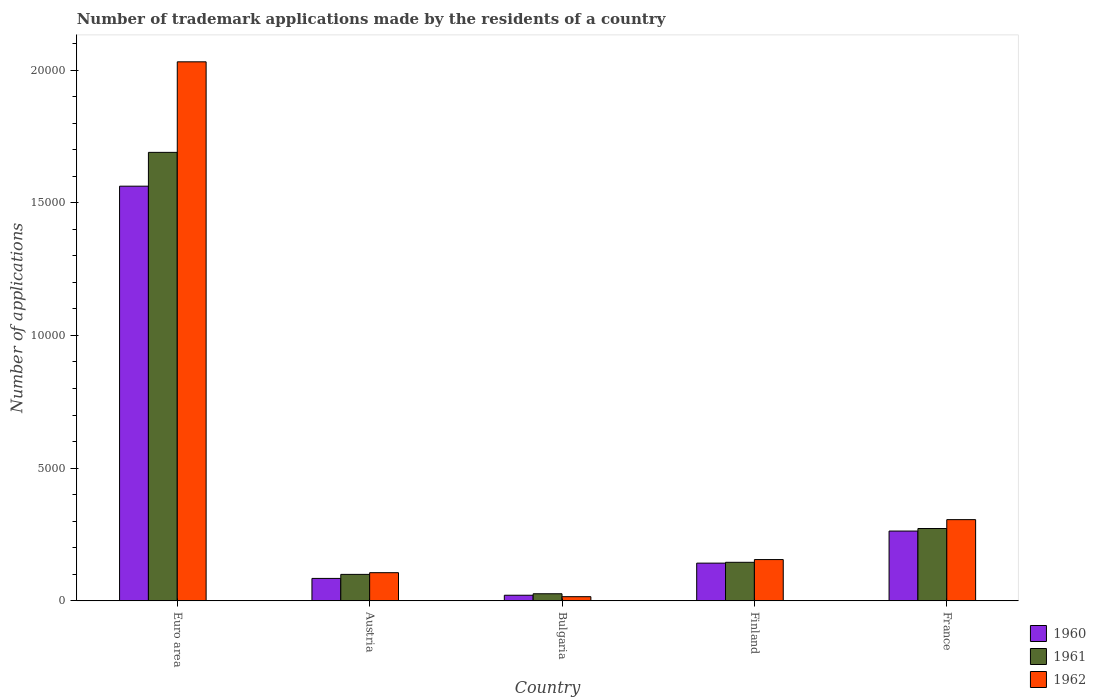How many groups of bars are there?
Provide a succinct answer. 5. Are the number of bars on each tick of the X-axis equal?
Provide a short and direct response. Yes. What is the label of the 4th group of bars from the left?
Ensure brevity in your answer.  Finland. In how many cases, is the number of bars for a given country not equal to the number of legend labels?
Make the answer very short. 0. What is the number of trademark applications made by the residents in 1962 in Euro area?
Make the answer very short. 2.03e+04. Across all countries, what is the maximum number of trademark applications made by the residents in 1960?
Your response must be concise. 1.56e+04. Across all countries, what is the minimum number of trademark applications made by the residents in 1962?
Provide a succinct answer. 157. In which country was the number of trademark applications made by the residents in 1960 minimum?
Provide a succinct answer. Bulgaria. What is the total number of trademark applications made by the residents in 1962 in the graph?
Provide a succinct answer. 2.61e+04. What is the difference between the number of trademark applications made by the residents in 1962 in Bulgaria and that in France?
Ensure brevity in your answer.  -2903. What is the difference between the number of trademark applications made by the residents in 1960 in Bulgaria and the number of trademark applications made by the residents in 1962 in Finland?
Offer a very short reply. -1344. What is the average number of trademark applications made by the residents in 1961 per country?
Provide a short and direct response. 4468.2. What is the difference between the number of trademark applications made by the residents of/in 1962 and number of trademark applications made by the residents of/in 1960 in Austria?
Your answer should be very brief. 216. What is the ratio of the number of trademark applications made by the residents in 1960 in Austria to that in France?
Make the answer very short. 0.32. What is the difference between the highest and the second highest number of trademark applications made by the residents in 1962?
Offer a terse response. -1505. What is the difference between the highest and the lowest number of trademark applications made by the residents in 1962?
Provide a short and direct response. 2.02e+04. In how many countries, is the number of trademark applications made by the residents in 1961 greater than the average number of trademark applications made by the residents in 1961 taken over all countries?
Provide a short and direct response. 1. Is the sum of the number of trademark applications made by the residents in 1962 in Euro area and France greater than the maximum number of trademark applications made by the residents in 1960 across all countries?
Make the answer very short. Yes. What does the 2nd bar from the left in Euro area represents?
Give a very brief answer. 1961. Is it the case that in every country, the sum of the number of trademark applications made by the residents in 1962 and number of trademark applications made by the residents in 1961 is greater than the number of trademark applications made by the residents in 1960?
Offer a very short reply. Yes. How many countries are there in the graph?
Offer a very short reply. 5. Are the values on the major ticks of Y-axis written in scientific E-notation?
Your answer should be compact. No. Does the graph contain any zero values?
Make the answer very short. No. How many legend labels are there?
Ensure brevity in your answer.  3. How are the legend labels stacked?
Provide a short and direct response. Vertical. What is the title of the graph?
Offer a terse response. Number of trademark applications made by the residents of a country. What is the label or title of the Y-axis?
Your answer should be very brief. Number of applications. What is the Number of applications in 1960 in Euro area?
Keep it short and to the point. 1.56e+04. What is the Number of applications in 1961 in Euro area?
Make the answer very short. 1.69e+04. What is the Number of applications of 1962 in Euro area?
Provide a succinct answer. 2.03e+04. What is the Number of applications in 1960 in Austria?
Your response must be concise. 845. What is the Number of applications of 1961 in Austria?
Offer a terse response. 997. What is the Number of applications of 1962 in Austria?
Offer a terse response. 1061. What is the Number of applications of 1960 in Bulgaria?
Your answer should be very brief. 211. What is the Number of applications of 1961 in Bulgaria?
Offer a very short reply. 267. What is the Number of applications in 1962 in Bulgaria?
Keep it short and to the point. 157. What is the Number of applications of 1960 in Finland?
Your response must be concise. 1421. What is the Number of applications of 1961 in Finland?
Offer a terse response. 1452. What is the Number of applications in 1962 in Finland?
Keep it short and to the point. 1555. What is the Number of applications of 1960 in France?
Offer a very short reply. 2630. What is the Number of applications of 1961 in France?
Make the answer very short. 2726. What is the Number of applications of 1962 in France?
Ensure brevity in your answer.  3060. Across all countries, what is the maximum Number of applications in 1960?
Provide a short and direct response. 1.56e+04. Across all countries, what is the maximum Number of applications in 1961?
Your answer should be very brief. 1.69e+04. Across all countries, what is the maximum Number of applications of 1962?
Ensure brevity in your answer.  2.03e+04. Across all countries, what is the minimum Number of applications of 1960?
Your response must be concise. 211. Across all countries, what is the minimum Number of applications in 1961?
Your answer should be very brief. 267. Across all countries, what is the minimum Number of applications of 1962?
Provide a succinct answer. 157. What is the total Number of applications of 1960 in the graph?
Provide a short and direct response. 2.07e+04. What is the total Number of applications of 1961 in the graph?
Provide a succinct answer. 2.23e+04. What is the total Number of applications of 1962 in the graph?
Offer a terse response. 2.61e+04. What is the difference between the Number of applications of 1960 in Euro area and that in Austria?
Keep it short and to the point. 1.48e+04. What is the difference between the Number of applications of 1961 in Euro area and that in Austria?
Make the answer very short. 1.59e+04. What is the difference between the Number of applications in 1962 in Euro area and that in Austria?
Make the answer very short. 1.92e+04. What is the difference between the Number of applications of 1960 in Euro area and that in Bulgaria?
Keep it short and to the point. 1.54e+04. What is the difference between the Number of applications of 1961 in Euro area and that in Bulgaria?
Offer a terse response. 1.66e+04. What is the difference between the Number of applications in 1962 in Euro area and that in Bulgaria?
Your answer should be compact. 2.02e+04. What is the difference between the Number of applications in 1960 in Euro area and that in Finland?
Provide a short and direct response. 1.42e+04. What is the difference between the Number of applications in 1961 in Euro area and that in Finland?
Your answer should be very brief. 1.54e+04. What is the difference between the Number of applications of 1962 in Euro area and that in Finland?
Offer a terse response. 1.88e+04. What is the difference between the Number of applications in 1960 in Euro area and that in France?
Make the answer very short. 1.30e+04. What is the difference between the Number of applications in 1961 in Euro area and that in France?
Offer a very short reply. 1.42e+04. What is the difference between the Number of applications in 1962 in Euro area and that in France?
Ensure brevity in your answer.  1.73e+04. What is the difference between the Number of applications in 1960 in Austria and that in Bulgaria?
Provide a succinct answer. 634. What is the difference between the Number of applications of 1961 in Austria and that in Bulgaria?
Your answer should be compact. 730. What is the difference between the Number of applications in 1962 in Austria and that in Bulgaria?
Offer a very short reply. 904. What is the difference between the Number of applications in 1960 in Austria and that in Finland?
Offer a terse response. -576. What is the difference between the Number of applications in 1961 in Austria and that in Finland?
Your answer should be very brief. -455. What is the difference between the Number of applications of 1962 in Austria and that in Finland?
Ensure brevity in your answer.  -494. What is the difference between the Number of applications of 1960 in Austria and that in France?
Offer a very short reply. -1785. What is the difference between the Number of applications of 1961 in Austria and that in France?
Give a very brief answer. -1729. What is the difference between the Number of applications of 1962 in Austria and that in France?
Ensure brevity in your answer.  -1999. What is the difference between the Number of applications of 1960 in Bulgaria and that in Finland?
Your answer should be compact. -1210. What is the difference between the Number of applications in 1961 in Bulgaria and that in Finland?
Provide a succinct answer. -1185. What is the difference between the Number of applications in 1962 in Bulgaria and that in Finland?
Make the answer very short. -1398. What is the difference between the Number of applications in 1960 in Bulgaria and that in France?
Keep it short and to the point. -2419. What is the difference between the Number of applications of 1961 in Bulgaria and that in France?
Provide a short and direct response. -2459. What is the difference between the Number of applications of 1962 in Bulgaria and that in France?
Offer a terse response. -2903. What is the difference between the Number of applications of 1960 in Finland and that in France?
Your response must be concise. -1209. What is the difference between the Number of applications of 1961 in Finland and that in France?
Make the answer very short. -1274. What is the difference between the Number of applications in 1962 in Finland and that in France?
Your answer should be compact. -1505. What is the difference between the Number of applications of 1960 in Euro area and the Number of applications of 1961 in Austria?
Give a very brief answer. 1.46e+04. What is the difference between the Number of applications of 1960 in Euro area and the Number of applications of 1962 in Austria?
Make the answer very short. 1.46e+04. What is the difference between the Number of applications in 1961 in Euro area and the Number of applications in 1962 in Austria?
Your answer should be very brief. 1.58e+04. What is the difference between the Number of applications in 1960 in Euro area and the Number of applications in 1961 in Bulgaria?
Your response must be concise. 1.54e+04. What is the difference between the Number of applications of 1960 in Euro area and the Number of applications of 1962 in Bulgaria?
Provide a succinct answer. 1.55e+04. What is the difference between the Number of applications in 1961 in Euro area and the Number of applications in 1962 in Bulgaria?
Give a very brief answer. 1.67e+04. What is the difference between the Number of applications in 1960 in Euro area and the Number of applications in 1961 in Finland?
Give a very brief answer. 1.42e+04. What is the difference between the Number of applications in 1960 in Euro area and the Number of applications in 1962 in Finland?
Offer a very short reply. 1.41e+04. What is the difference between the Number of applications of 1961 in Euro area and the Number of applications of 1962 in Finland?
Your answer should be compact. 1.53e+04. What is the difference between the Number of applications in 1960 in Euro area and the Number of applications in 1961 in France?
Provide a short and direct response. 1.29e+04. What is the difference between the Number of applications of 1960 in Euro area and the Number of applications of 1962 in France?
Offer a terse response. 1.26e+04. What is the difference between the Number of applications in 1961 in Euro area and the Number of applications in 1962 in France?
Offer a very short reply. 1.38e+04. What is the difference between the Number of applications of 1960 in Austria and the Number of applications of 1961 in Bulgaria?
Keep it short and to the point. 578. What is the difference between the Number of applications in 1960 in Austria and the Number of applications in 1962 in Bulgaria?
Ensure brevity in your answer.  688. What is the difference between the Number of applications in 1961 in Austria and the Number of applications in 1962 in Bulgaria?
Keep it short and to the point. 840. What is the difference between the Number of applications of 1960 in Austria and the Number of applications of 1961 in Finland?
Make the answer very short. -607. What is the difference between the Number of applications in 1960 in Austria and the Number of applications in 1962 in Finland?
Keep it short and to the point. -710. What is the difference between the Number of applications of 1961 in Austria and the Number of applications of 1962 in Finland?
Offer a terse response. -558. What is the difference between the Number of applications in 1960 in Austria and the Number of applications in 1961 in France?
Offer a very short reply. -1881. What is the difference between the Number of applications of 1960 in Austria and the Number of applications of 1962 in France?
Provide a succinct answer. -2215. What is the difference between the Number of applications of 1961 in Austria and the Number of applications of 1962 in France?
Provide a succinct answer. -2063. What is the difference between the Number of applications of 1960 in Bulgaria and the Number of applications of 1961 in Finland?
Your answer should be very brief. -1241. What is the difference between the Number of applications in 1960 in Bulgaria and the Number of applications in 1962 in Finland?
Offer a terse response. -1344. What is the difference between the Number of applications in 1961 in Bulgaria and the Number of applications in 1962 in Finland?
Offer a terse response. -1288. What is the difference between the Number of applications of 1960 in Bulgaria and the Number of applications of 1961 in France?
Make the answer very short. -2515. What is the difference between the Number of applications in 1960 in Bulgaria and the Number of applications in 1962 in France?
Your answer should be very brief. -2849. What is the difference between the Number of applications of 1961 in Bulgaria and the Number of applications of 1962 in France?
Offer a terse response. -2793. What is the difference between the Number of applications in 1960 in Finland and the Number of applications in 1961 in France?
Your response must be concise. -1305. What is the difference between the Number of applications of 1960 in Finland and the Number of applications of 1962 in France?
Offer a terse response. -1639. What is the difference between the Number of applications of 1961 in Finland and the Number of applications of 1962 in France?
Keep it short and to the point. -1608. What is the average Number of applications in 1960 per country?
Your response must be concise. 4146.4. What is the average Number of applications in 1961 per country?
Offer a very short reply. 4468.2. What is the average Number of applications of 1962 per country?
Give a very brief answer. 5228.8. What is the difference between the Number of applications in 1960 and Number of applications in 1961 in Euro area?
Offer a terse response. -1274. What is the difference between the Number of applications of 1960 and Number of applications of 1962 in Euro area?
Give a very brief answer. -4686. What is the difference between the Number of applications of 1961 and Number of applications of 1962 in Euro area?
Keep it short and to the point. -3412. What is the difference between the Number of applications in 1960 and Number of applications in 1961 in Austria?
Give a very brief answer. -152. What is the difference between the Number of applications in 1960 and Number of applications in 1962 in Austria?
Make the answer very short. -216. What is the difference between the Number of applications in 1961 and Number of applications in 1962 in Austria?
Your response must be concise. -64. What is the difference between the Number of applications of 1960 and Number of applications of 1961 in Bulgaria?
Your answer should be compact. -56. What is the difference between the Number of applications in 1961 and Number of applications in 1962 in Bulgaria?
Provide a succinct answer. 110. What is the difference between the Number of applications of 1960 and Number of applications of 1961 in Finland?
Offer a terse response. -31. What is the difference between the Number of applications of 1960 and Number of applications of 1962 in Finland?
Offer a terse response. -134. What is the difference between the Number of applications of 1961 and Number of applications of 1962 in Finland?
Offer a very short reply. -103. What is the difference between the Number of applications of 1960 and Number of applications of 1961 in France?
Offer a terse response. -96. What is the difference between the Number of applications of 1960 and Number of applications of 1962 in France?
Ensure brevity in your answer.  -430. What is the difference between the Number of applications in 1961 and Number of applications in 1962 in France?
Provide a short and direct response. -334. What is the ratio of the Number of applications of 1960 in Euro area to that in Austria?
Give a very brief answer. 18.49. What is the ratio of the Number of applications in 1961 in Euro area to that in Austria?
Your response must be concise. 16.95. What is the ratio of the Number of applications in 1962 in Euro area to that in Austria?
Your response must be concise. 19.14. What is the ratio of the Number of applications in 1960 in Euro area to that in Bulgaria?
Offer a terse response. 74.05. What is the ratio of the Number of applications in 1961 in Euro area to that in Bulgaria?
Your answer should be very brief. 63.29. What is the ratio of the Number of applications in 1962 in Euro area to that in Bulgaria?
Your answer should be compact. 129.37. What is the ratio of the Number of applications of 1960 in Euro area to that in Finland?
Provide a short and direct response. 11. What is the ratio of the Number of applications in 1961 in Euro area to that in Finland?
Your response must be concise. 11.64. What is the ratio of the Number of applications of 1962 in Euro area to that in Finland?
Offer a terse response. 13.06. What is the ratio of the Number of applications in 1960 in Euro area to that in France?
Make the answer very short. 5.94. What is the ratio of the Number of applications of 1961 in Euro area to that in France?
Give a very brief answer. 6.2. What is the ratio of the Number of applications in 1962 in Euro area to that in France?
Offer a terse response. 6.64. What is the ratio of the Number of applications in 1960 in Austria to that in Bulgaria?
Provide a succinct answer. 4. What is the ratio of the Number of applications in 1961 in Austria to that in Bulgaria?
Your response must be concise. 3.73. What is the ratio of the Number of applications in 1962 in Austria to that in Bulgaria?
Provide a short and direct response. 6.76. What is the ratio of the Number of applications of 1960 in Austria to that in Finland?
Ensure brevity in your answer.  0.59. What is the ratio of the Number of applications in 1961 in Austria to that in Finland?
Give a very brief answer. 0.69. What is the ratio of the Number of applications of 1962 in Austria to that in Finland?
Give a very brief answer. 0.68. What is the ratio of the Number of applications in 1960 in Austria to that in France?
Offer a very short reply. 0.32. What is the ratio of the Number of applications in 1961 in Austria to that in France?
Provide a succinct answer. 0.37. What is the ratio of the Number of applications of 1962 in Austria to that in France?
Your answer should be very brief. 0.35. What is the ratio of the Number of applications of 1960 in Bulgaria to that in Finland?
Make the answer very short. 0.15. What is the ratio of the Number of applications of 1961 in Bulgaria to that in Finland?
Keep it short and to the point. 0.18. What is the ratio of the Number of applications in 1962 in Bulgaria to that in Finland?
Your answer should be very brief. 0.1. What is the ratio of the Number of applications in 1960 in Bulgaria to that in France?
Offer a terse response. 0.08. What is the ratio of the Number of applications of 1961 in Bulgaria to that in France?
Your answer should be very brief. 0.1. What is the ratio of the Number of applications of 1962 in Bulgaria to that in France?
Offer a terse response. 0.05. What is the ratio of the Number of applications in 1960 in Finland to that in France?
Your answer should be compact. 0.54. What is the ratio of the Number of applications in 1961 in Finland to that in France?
Your response must be concise. 0.53. What is the ratio of the Number of applications of 1962 in Finland to that in France?
Offer a terse response. 0.51. What is the difference between the highest and the second highest Number of applications of 1960?
Ensure brevity in your answer.  1.30e+04. What is the difference between the highest and the second highest Number of applications in 1961?
Ensure brevity in your answer.  1.42e+04. What is the difference between the highest and the second highest Number of applications of 1962?
Give a very brief answer. 1.73e+04. What is the difference between the highest and the lowest Number of applications of 1960?
Your answer should be compact. 1.54e+04. What is the difference between the highest and the lowest Number of applications of 1961?
Make the answer very short. 1.66e+04. What is the difference between the highest and the lowest Number of applications in 1962?
Make the answer very short. 2.02e+04. 